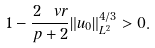Convert formula to latex. <formula><loc_0><loc_0><loc_500><loc_500>1 - \frac { 2 \ v r } { p + 2 } \| u _ { 0 } \| _ { L ^ { 2 } } ^ { 4 / 3 } > 0 .</formula> 